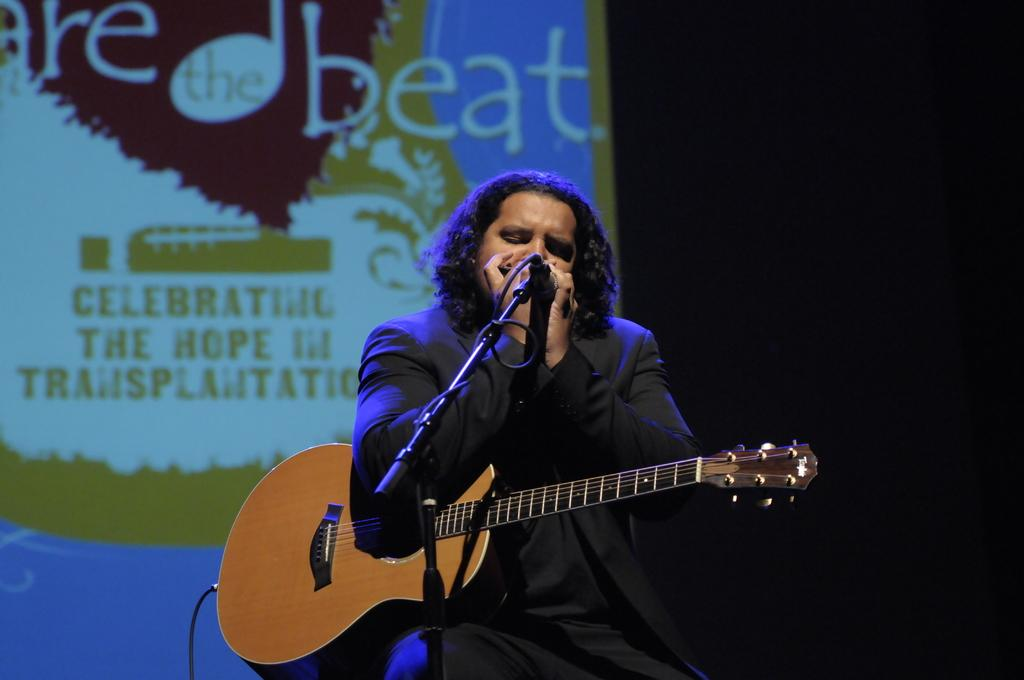What is present in the image that is not a person or an object? There is a banner in the image. Can you describe the man in the image? The man in the image is wearing a black jacket and is singing a song. What is the man holding in the image? The man is holding a microphone and a guitar. How many girls are visible in the image? There are no girls present in the image; it features a man singing with a microphone and a guitar. What type of clouds can be seen in the image? There are no clouds visible in the image; it is focused on the man and his performance. 